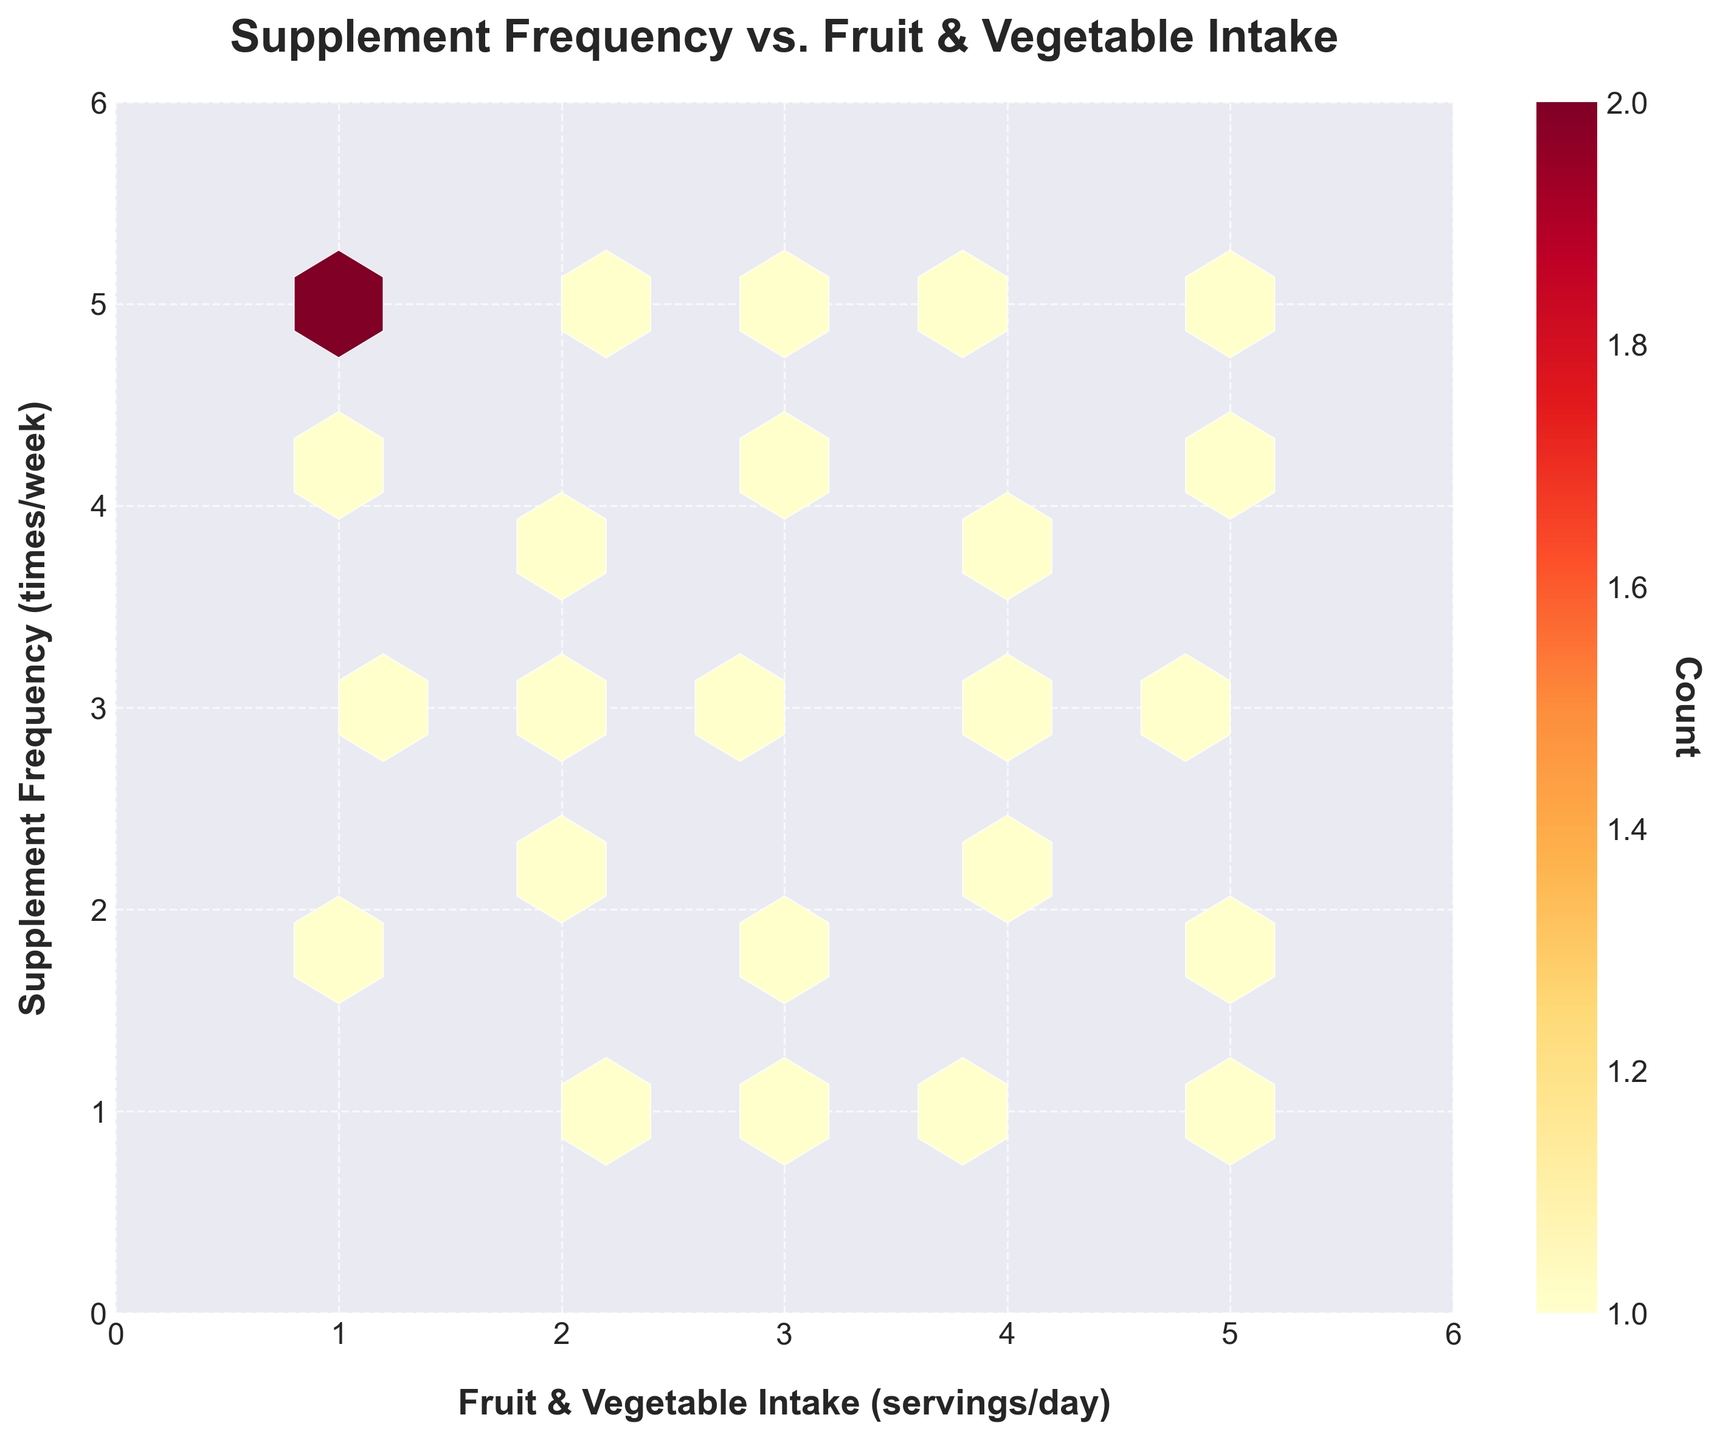What is the title of the plot? Look at the top of the plot where the title is usually located. The title provides an overview of the plot's purpose.
Answer: Supplement Frequency vs. Fruit & Vegetable Intake What do the axes represent in the plot? The x-axis label is at the bottom and the y-axis label is on the left side of the plot. These labels explain what each axis represents.
Answer: The x-axis represents Fruit & Vegetable Intake (servings/day) and the y-axis represents Supplement Frequency (times/week) How many hexagons are shown in the plot? Observe all the hexagonal bins in the plot. Each hexagon represents a bin with a count of data points within a specific range.
Answer: There are 25 hexagons in the plot Is there a positive correlation between fruit and vegetable intake and supplement frequency? Notice the general trend of the hexagons with higher counts towards the top right. This implies that as one variable increases, so does the other, indicating a positive correlation.
Answer: Yes, there seems to be a positive correlation Which range of fruit and vegetable intake has the highest frequency of supplement usage? Look at the concentration of color intensity within the hexagons at the top right and refer to the x-axis range. The darkest hexagons indicate the highest counts.
Answer: The range of 4-5 servings/day of fruit and vegetable intake has the highest frequency of supplement usage How many times do people with a fruit & vegetable intake of 2 servings/day take supplements on average? Focus on the hexagons along the x-axis value of 2. Determine the placement and counts of those hexagons to estimate the average supplement frequency.
Answer: They take supplements approximately 2-5 times/week What is the color used to indicate hexagons with the highest count? Examine the color bar to the right, which shows the gradient used for counts. The highest counts correspond to the darkest color.
Answer: Dark red (or close to it) Are there any hexagons with a count of 1? On the color bar, the lowest value to the right indicates a count of 1. Compare this with the lightest color on the hexagons.
Answer: Yes, there are hexagons with a count of 1 In which intake range do the highest number of people fall? Check the darkest hexagons and note their position along the x-axis. The darkest hexagon indicates the highest count of people.
Answer: 3-4 servings/day range for fruit and vegetable intake Which specific intake and frequency combination has a count of 3? Refer to the color bar for the color representing a count of 3. Then look at the hexagons to identify the one or more that match this color.
Answer: One of the combinations is at (2, 4) for fruit/vegetable intake and supplement frequency 